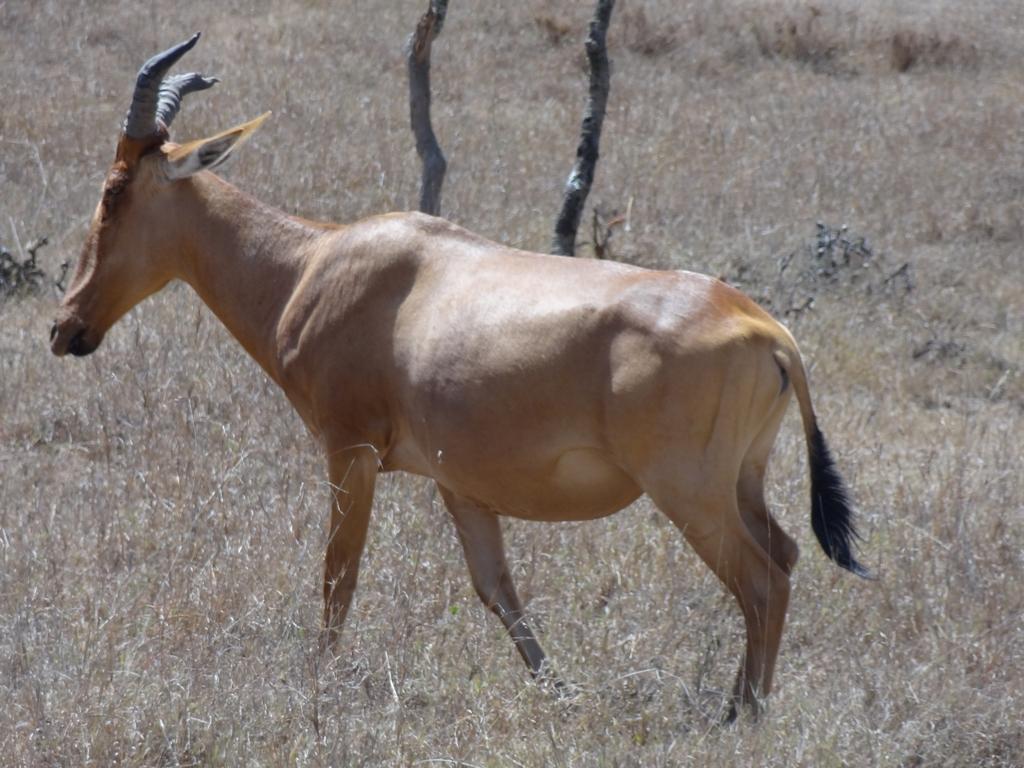Could you give a brief overview of what you see in this image? In the picture there is an animal and around the animal there is a lot of dry grass and there are two dry trees behind the animal. 